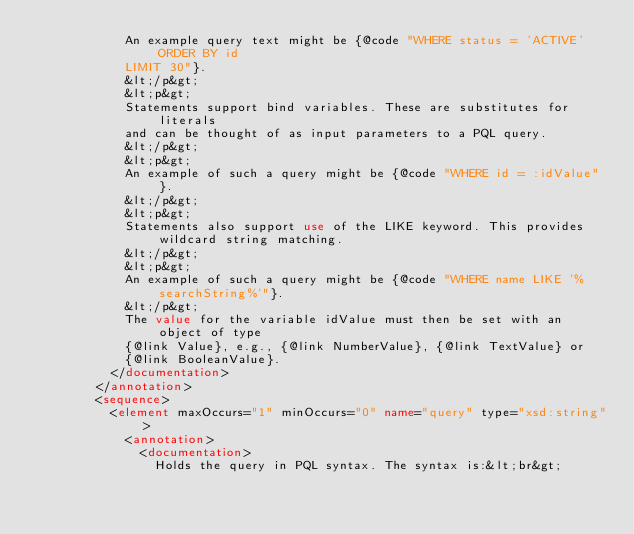Convert code to text. <code><loc_0><loc_0><loc_500><loc_500><_XML_>            An example query text might be {@code "WHERE status = 'ACTIVE' ORDER BY id
            LIMIT 30"}.
            &lt;/p&gt;
            &lt;p&gt;
            Statements support bind variables. These are substitutes for literals
            and can be thought of as input parameters to a PQL query.
            &lt;/p&gt;
            &lt;p&gt;
            An example of such a query might be {@code "WHERE id = :idValue"}.
            &lt;/p&gt;
            &lt;p&gt;
            Statements also support use of the LIKE keyword. This provides wildcard string matching.
            &lt;/p&gt;
            &lt;p&gt;
            An example of such a query might be {@code "WHERE name LIKE '%searchString%'"}.
            &lt;/p&gt;
            The value for the variable idValue must then be set with an object of type
            {@link Value}, e.g., {@link NumberValue}, {@link TextValue} or
            {@link BooleanValue}.
          </documentation>
        </annotation>
        <sequence>
          <element maxOccurs="1" minOccurs="0" name="query" type="xsd:string">
            <annotation>
              <documentation>
                Holds the query in PQL syntax. The syntax is:&lt;br&gt;</code> 